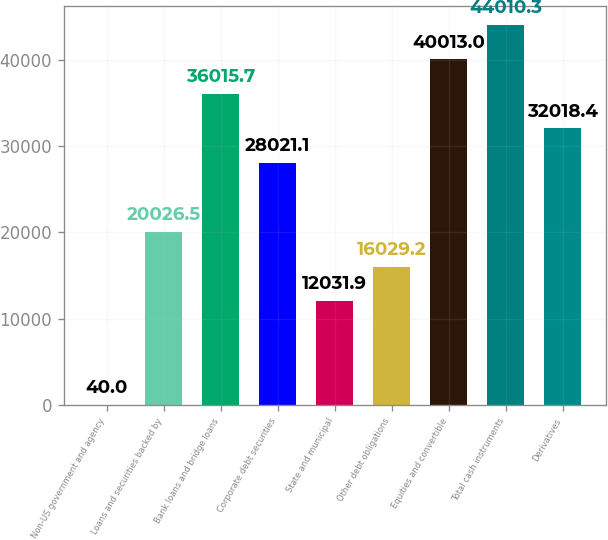Convert chart. <chart><loc_0><loc_0><loc_500><loc_500><bar_chart><fcel>Non-US government and agency<fcel>Loans and securities backed by<fcel>Bank loans and bridge loans<fcel>Corporate debt securities<fcel>State and municipal<fcel>Other debt obligations<fcel>Equities and convertible<fcel>Total cash instruments<fcel>Derivatives<nl><fcel>40<fcel>20026.5<fcel>36015.7<fcel>28021.1<fcel>12031.9<fcel>16029.2<fcel>40013<fcel>44010.3<fcel>32018.4<nl></chart> 